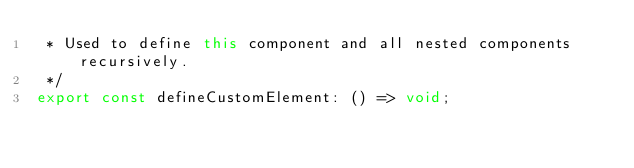<code> <loc_0><loc_0><loc_500><loc_500><_TypeScript_> * Used to define this component and all nested components recursively.
 */
export const defineCustomElement: () => void;
</code> 